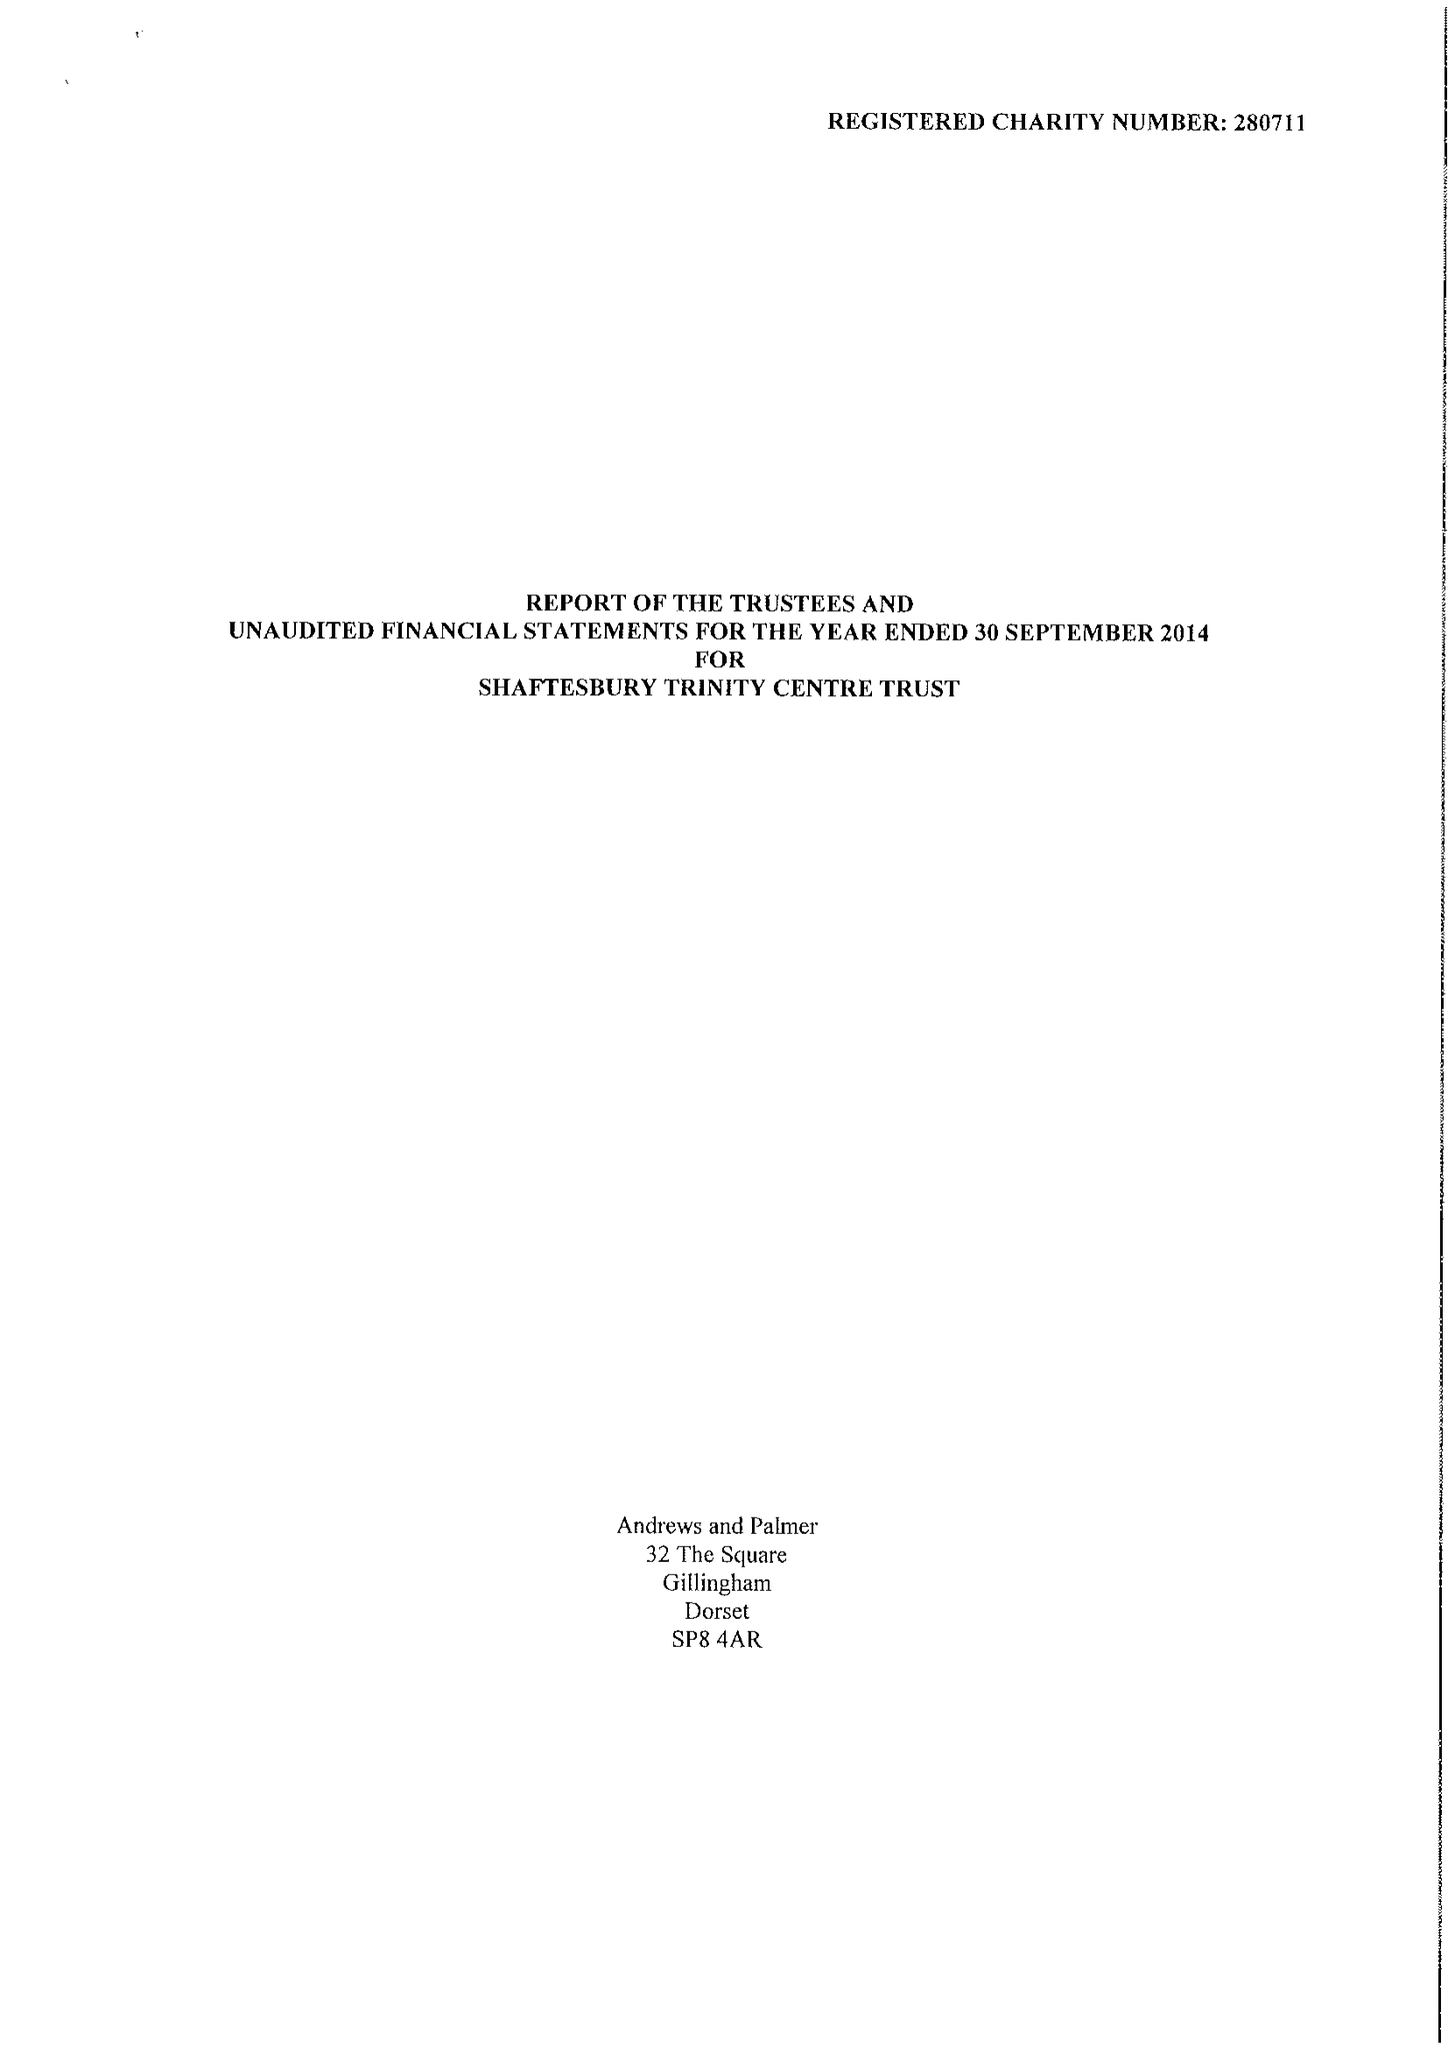What is the value for the address__post_town?
Answer the question using a single word or phrase. GILLINGHAM 